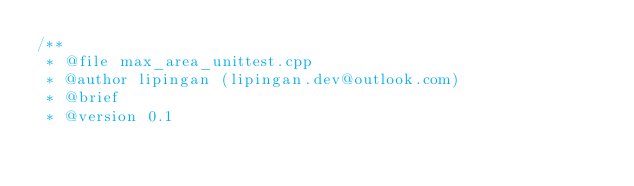<code> <loc_0><loc_0><loc_500><loc_500><_C++_>/**
 * @file max_area_unittest.cpp
 * @author lipingan (lipingan.dev@outlook.com)
 * @brief
 * @version 0.1</code> 